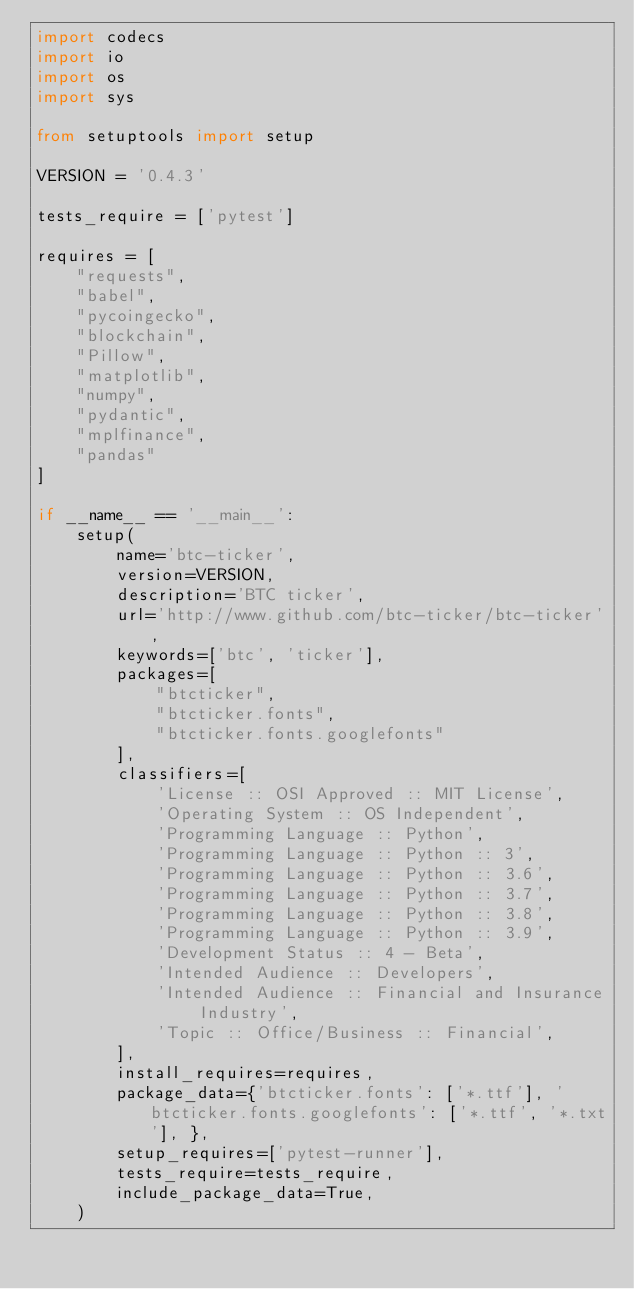<code> <loc_0><loc_0><loc_500><loc_500><_Python_>import codecs
import io
import os
import sys

from setuptools import setup

VERSION = '0.4.3'

tests_require = ['pytest']

requires = [
    "requests",
    "babel",
    "pycoingecko",
    "blockchain",
    "Pillow",
    "matplotlib",
    "numpy",
    "pydantic",
    "mplfinance",
    "pandas"
]

if __name__ == '__main__':
    setup(
        name='btc-ticker',
        version=VERSION,
        description='BTC ticker',
        url='http://www.github.com/btc-ticker/btc-ticker',
        keywords=['btc', 'ticker'],
        packages=[
            "btcticker",
            "btcticker.fonts",
            "btcticker.fonts.googlefonts"
        ],
        classifiers=[
            'License :: OSI Approved :: MIT License',
            'Operating System :: OS Independent',
            'Programming Language :: Python',
            'Programming Language :: Python :: 3',
            'Programming Language :: Python :: 3.6',
            'Programming Language :: Python :: 3.7',
            'Programming Language :: Python :: 3.8',
            'Programming Language :: Python :: 3.9',
            'Development Status :: 4 - Beta',
            'Intended Audience :: Developers',
            'Intended Audience :: Financial and Insurance Industry',
            'Topic :: Office/Business :: Financial',
        ],
        install_requires=requires,
        package_data={'btcticker.fonts': ['*.ttf'], 'btcticker.fonts.googlefonts': ['*.ttf', '*.txt'], },
        setup_requires=['pytest-runner'],
        tests_require=tests_require,
        include_package_data=True,
    )</code> 